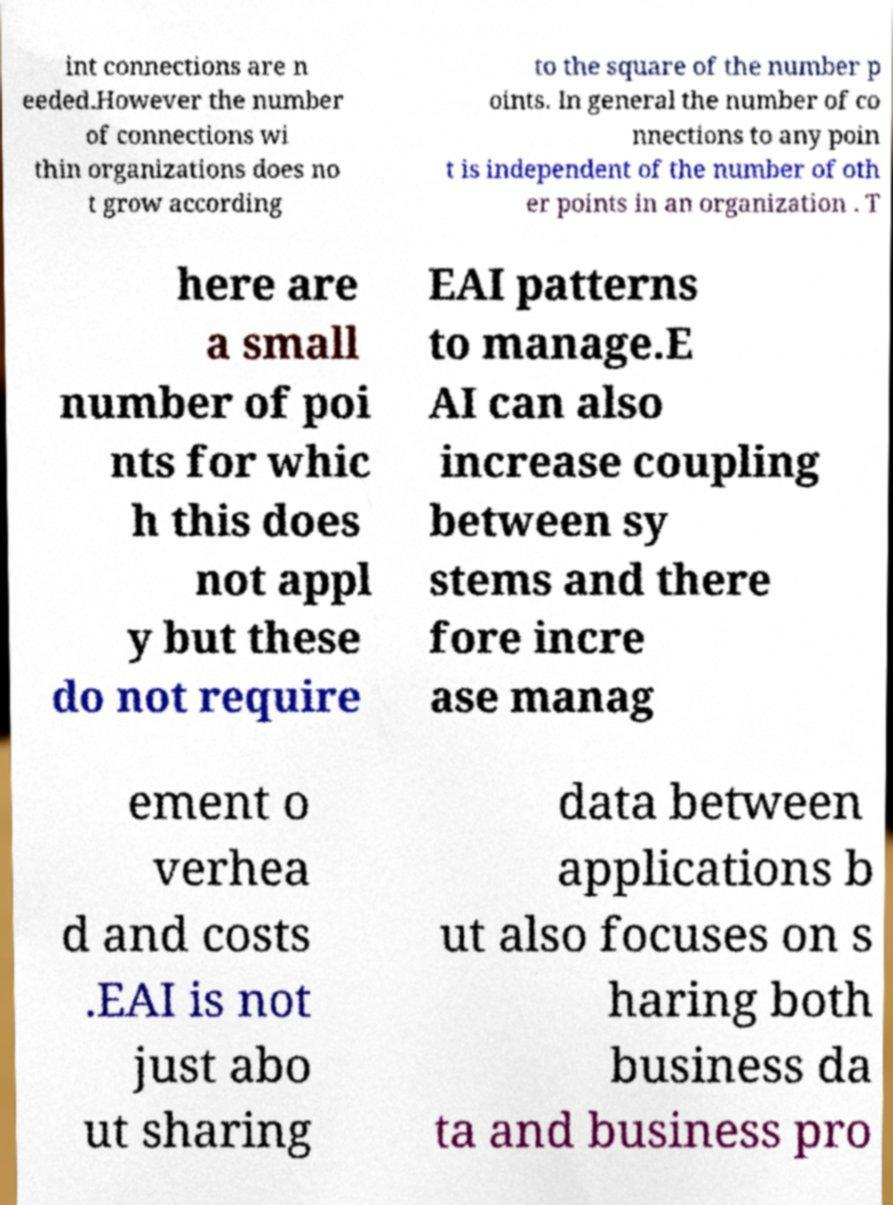What messages or text are displayed in this image? I need them in a readable, typed format. int connections are n eeded.However the number of connections wi thin organizations does no t grow according to the square of the number p oints. In general the number of co nnections to any poin t is independent of the number of oth er points in an organization . T here are a small number of poi nts for whic h this does not appl y but these do not require EAI patterns to manage.E AI can also increase coupling between sy stems and there fore incre ase manag ement o verhea d and costs .EAI is not just abo ut sharing data between applications b ut also focuses on s haring both business da ta and business pro 